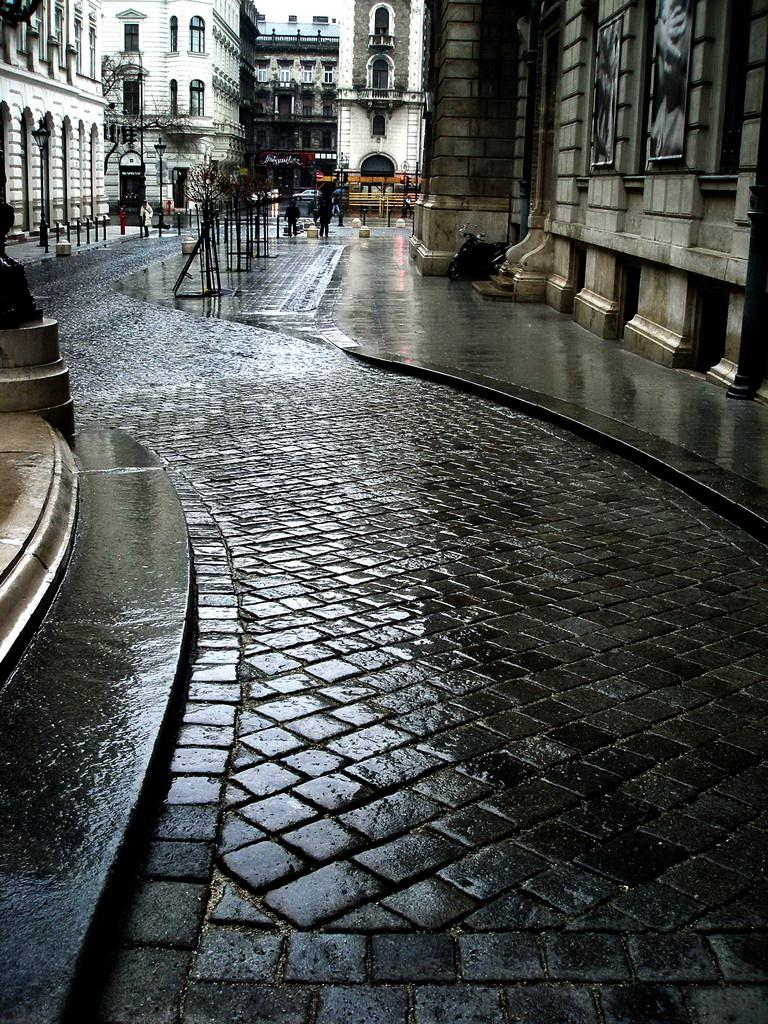What type of path is present in the image? There is a walkway and a footpath in the image. What kind of structures can be seen in the image? There are buildings with walls and windows in the image. Can you describe the people visible in the image? There are people visible in the image. What else is present in the image besides the walkway, footpath, and buildings? There are objects present in the image. What type of ship can be seen sailing in harmony with the buildings in the image? There is no ship present in the image; it only features a walkway, footpath, buildings, people, and objects. What flavor of mint is being used to decorate the buildings in the image? There is no mint present in the image, and the buildings are not decorated with mint. 